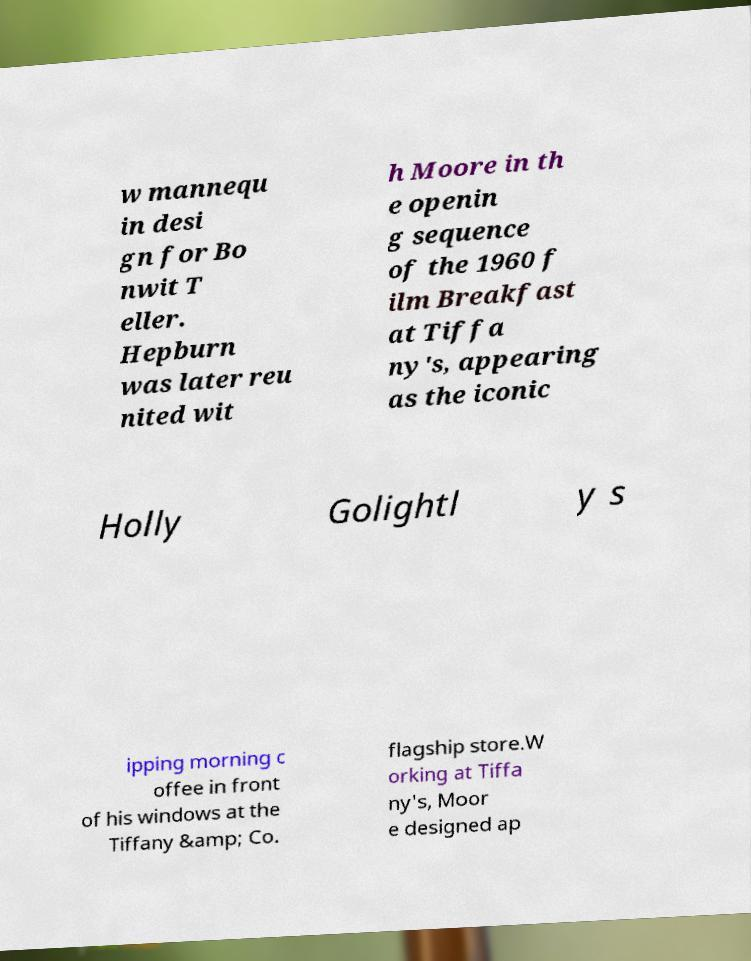I need the written content from this picture converted into text. Can you do that? w mannequ in desi gn for Bo nwit T eller. Hepburn was later reu nited wit h Moore in th e openin g sequence of the 1960 f ilm Breakfast at Tiffa ny's, appearing as the iconic Holly Golightl y s ipping morning c offee in front of his windows at the Tiffany &amp; Co. flagship store.W orking at Tiffa ny's, Moor e designed ap 